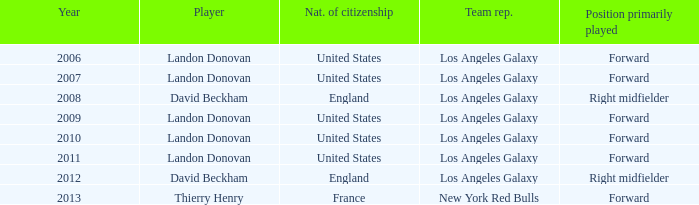What is the sum of all the years that Landon Donovan won the ESPY award? 5.0. 